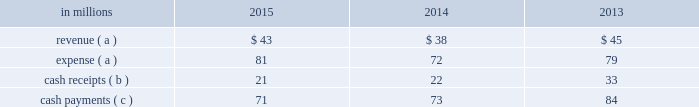Credit and therefore was not the primary beneficiary at december 31 , 2014 .
The company 2019s maximum exposure to loss at december 31 , 2014 equaled the principal amount of the timber notes ; however , an analysis performed by the company concluded the likelihood of this exposure was remote .
During the third quarter of 2015 , we initiated a series of actions in order to extend the 2006 monetization structure and maintain the long-term nature of the $ 1.4 billion deferred tax liability .
First , international paper acquired the class a interests in the investor entities from a third party for $ 198 million in cash .
As a result , international paper became the owner of all of the class a and class b interests in the entities and became the primary beneficiary of the entities .
The assets and liabilities of the entities , primarily consisting of the timber notes and third party bank loans , were recorded at fair value as of the acquisition date of the class a interests .
Subsequent to purchasing the class a interests in the investor entities , international paper restructured the entities , which resulted in the formation of wholly- owned , bankruptcy-remote special purpose entities ( the 2015 financing entities ) .
As part of the restructuring , the timber notes held by the borrower entities , subject to the third party bank loans , were contributed to the 2015 financing entities along with approximately $ 150 million in international paper debt obligations , approximately $ 600 million in cash and approximately $ 130 million in demand loans from international paper , and certain entities were liquidated .
As a result of these transactions , international paper began consolidating the 2015 financing entities during the third quarter of 2015 .
Also , during the third quarter of 2015 , the 2015 financing entities used $ 630 million in cash to pay down a portion of the third party bank loans and refinanced approximately $ 4.2 billion of those loans on nonrecourse terms ( the 2015 refinance loans ) .
During the fourth quarter of 2015 , international paper extended the maturity date on the timber notes for an additional five years .
The timber notes are shown in financial assets of special purpose entities on the accompanying consolidated balance sheet and mature in august 2021 unless extended for an additional five years .
These notes are supported by approximately $ 4.8 billion of irrevocable letters of credit .
In addition , the company extinguished the 2015 refinance loans scheduled to mature in may 2016 and entered into new nonrecourse third party bank loans totaling approximately $ 4.2 billion ( the extension loans ) .
Provisions of loan agreements related to approximately $ 1.1 billion of the extension loans require the bank issuing letters of credit supporting the timber notes pledged as collateral to maintain a credit rating at or above a specified threshold .
In the event the credit rating of the letter of credit bank is downgraded below the specified threshold , the letters of credit must be replaced within 60 days with letters of credit from a qualifying financial institution .
The extension loans are shown in nonrecourse financial liabilities of special purpose entities on the accompanying consolidated balance sheet and mature in the fourth quarter of 2020 .
The extinguishment of the 2015 refinance loans of approximately $ 4.2 billion and the issuance of the extension loans of approximately $ 4.2 billion are shown as part of reductions of debt and issuances of debt , respectively , in the financing activities of the consolidated statement of cash flows .
The extension loans are nonrecourse to the company , and are secured by approximately $ 4.8 billion of timber notes , the irrevocable letters of credit supporting the timber notes and approximately $ 150 million of international paper debt obligations .
The $ 150 million of international paper debt obligations are eliminated in the consolidation of the 2015 financing entities and are not reflected in the company 2019s consolidated balance sheet .
The purchase of the class a interests and subsequent restructuring described above facilitated the refinancing and extensions of the third party bank loans on nonrecourse terms .
The transactions described in these paragraphs result in continued long-term classification of the $ 1.4 billion deferred tax liability recognized in connection with the 2006 forestlands as of december 31 , 2015 , the fair value of the timber notes and extension loans is $ 4.68 billion and $ 4.28 billion , respectively .
The timber notes and extension loans are classified as level 2 within the fair value hierarchy , which is further defined in note 14 .
Activity between the company and the 2015 financing entities ( the entities prior to the purchase of the class a interest discussed above ) was as follows: .
( a ) the net expense related to the company 2019s interest in the entities is included in the accompanying consolidated statement of operations , as international paper has and intends to effect its legal right to offset as discussed above .
After formation of the 2015 financing entities , the revenue and expense are included in interest expense , net in the accompanying consolidated statement of operations .
( b ) the cash receipts are equity distributions from the entities to international paper prior to the formation of the 2015 financing entities .
After formation of the 2015 financing entities , cash receipts are interest received on the financial assets of special purpose entities. .
Based on the review of the activity between the company and the 2015 financing entities what was the ratio of the cash payments to cash receipts in 2013? 
Computations: (84 / 33)
Answer: 2.54545. 